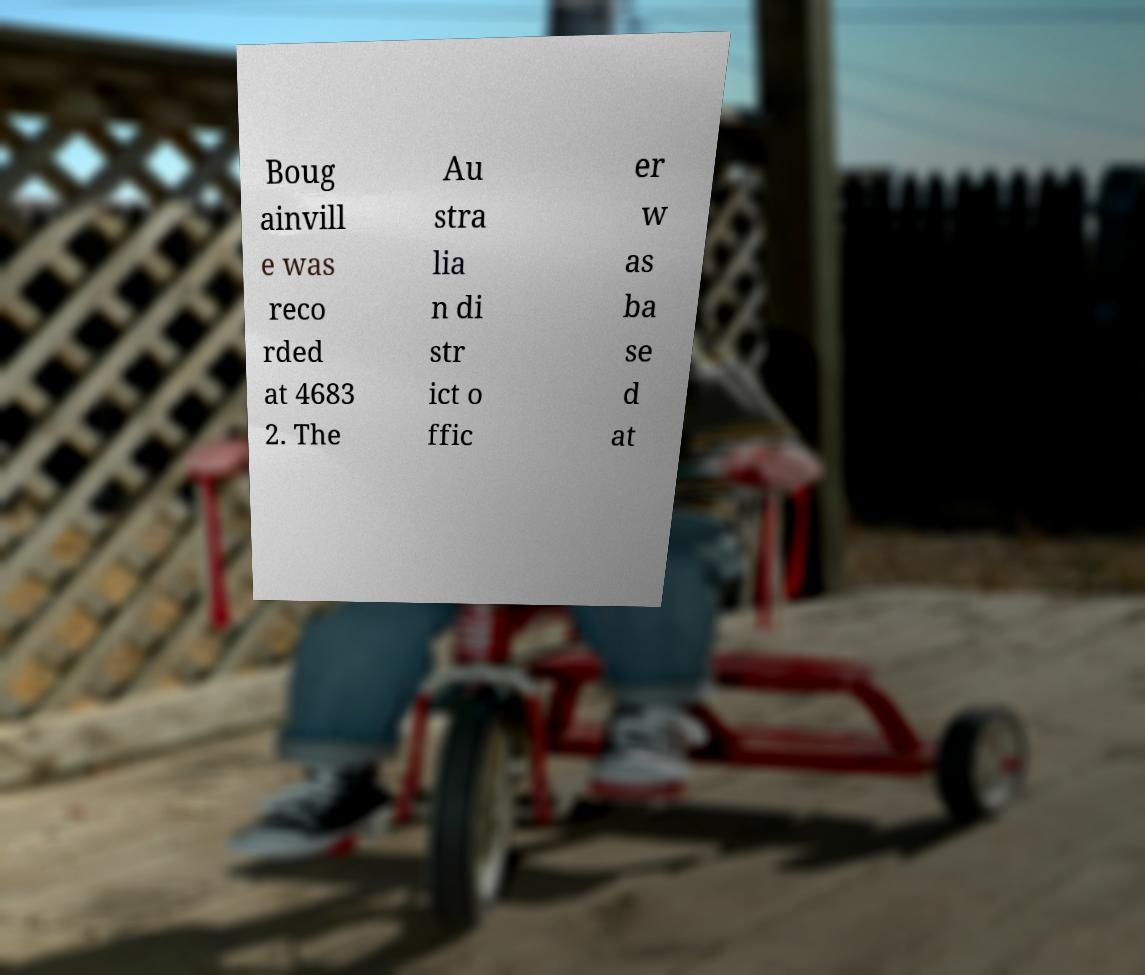What messages or text are displayed in this image? I need them in a readable, typed format. Boug ainvill e was reco rded at 4683 2. The Au stra lia n di str ict o ffic er w as ba se d at 